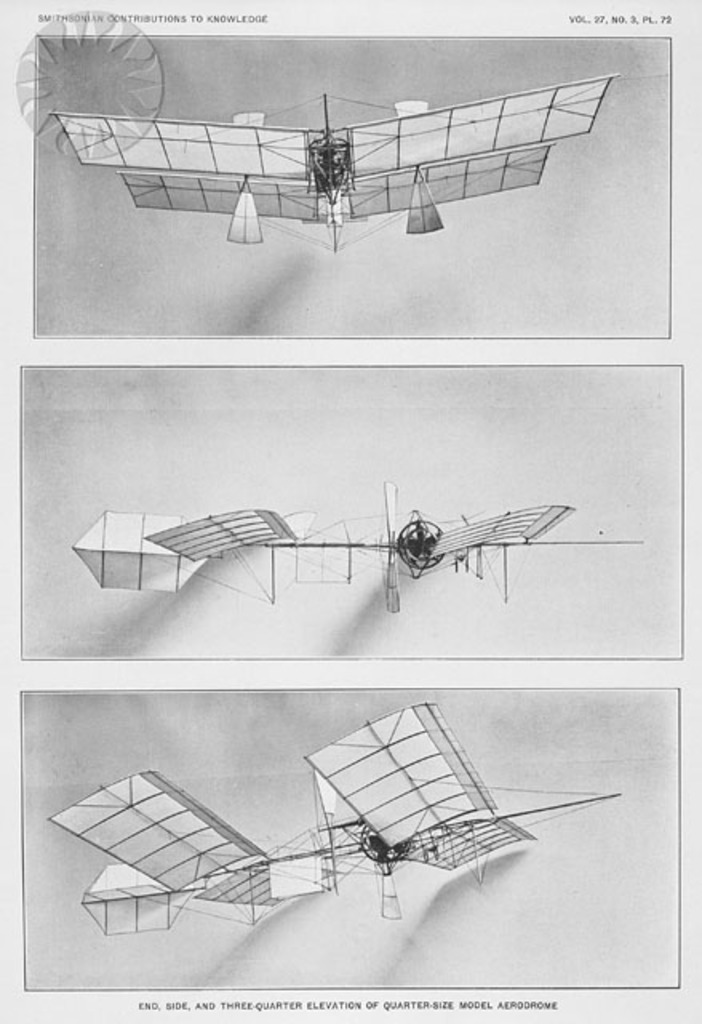Provide a one-sentence caption for the provided image. The image displays detailed multiple perspectives—end, side, and three-quarter elevation—of a quarter-size model aerodrome, likely from an early aviation research exhibit, possibly part of Smithsonian documentation. 